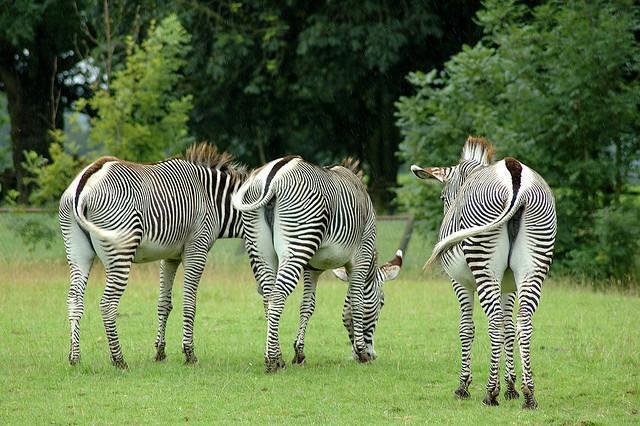How many zebras are there?
Give a very brief answer. 3. 